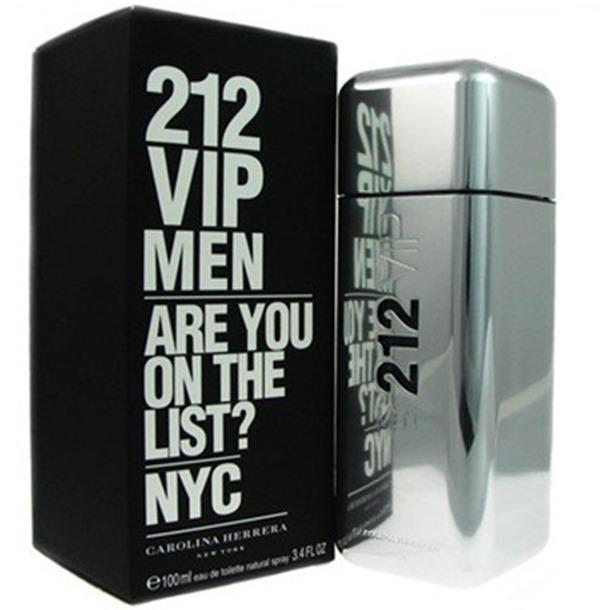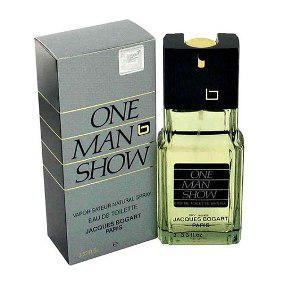The first image is the image on the left, the second image is the image on the right. Examine the images to the left and right. Is the description "There is a total of 1 black box." accurate? Answer yes or no. Yes. 